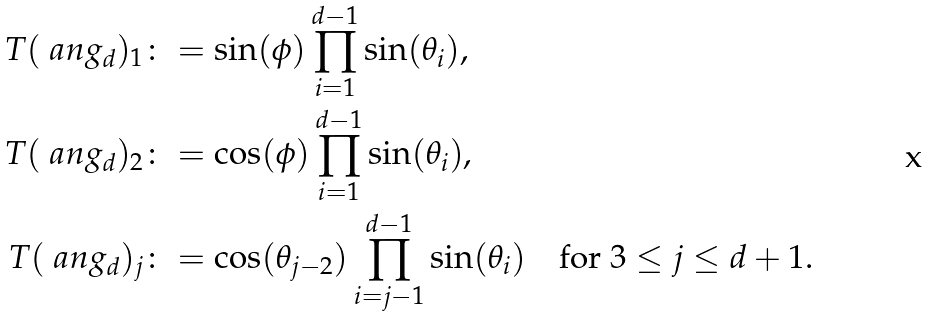Convert formula to latex. <formula><loc_0><loc_0><loc_500><loc_500>T ( \ a n g _ { d } ) _ { 1 } & \colon = \sin ( \phi ) \prod _ { i = 1 } ^ { d - 1 } \sin ( \theta _ { i } ) , \\ T ( \ a n g _ { d } ) _ { 2 } & \colon = \cos ( \phi ) \prod _ { i = 1 } ^ { d - 1 } \sin ( \theta _ { i } ) , \\ T ( \ a n g _ { d } ) _ { j } & \colon = \cos ( \theta _ { j - 2 } ) \prod _ { i = j - 1 } ^ { d - 1 } \sin ( \theta _ { i } ) \quad \text {for $3\leq j\leq d+1$} .</formula> 